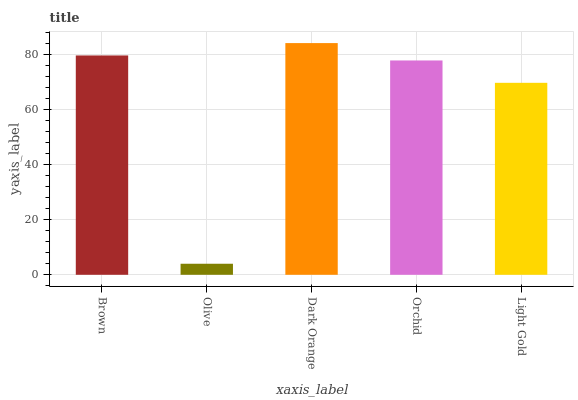Is Olive the minimum?
Answer yes or no. Yes. Is Dark Orange the maximum?
Answer yes or no. Yes. Is Dark Orange the minimum?
Answer yes or no. No. Is Olive the maximum?
Answer yes or no. No. Is Dark Orange greater than Olive?
Answer yes or no. Yes. Is Olive less than Dark Orange?
Answer yes or no. Yes. Is Olive greater than Dark Orange?
Answer yes or no. No. Is Dark Orange less than Olive?
Answer yes or no. No. Is Orchid the high median?
Answer yes or no. Yes. Is Orchid the low median?
Answer yes or no. Yes. Is Olive the high median?
Answer yes or no. No. Is Light Gold the low median?
Answer yes or no. No. 